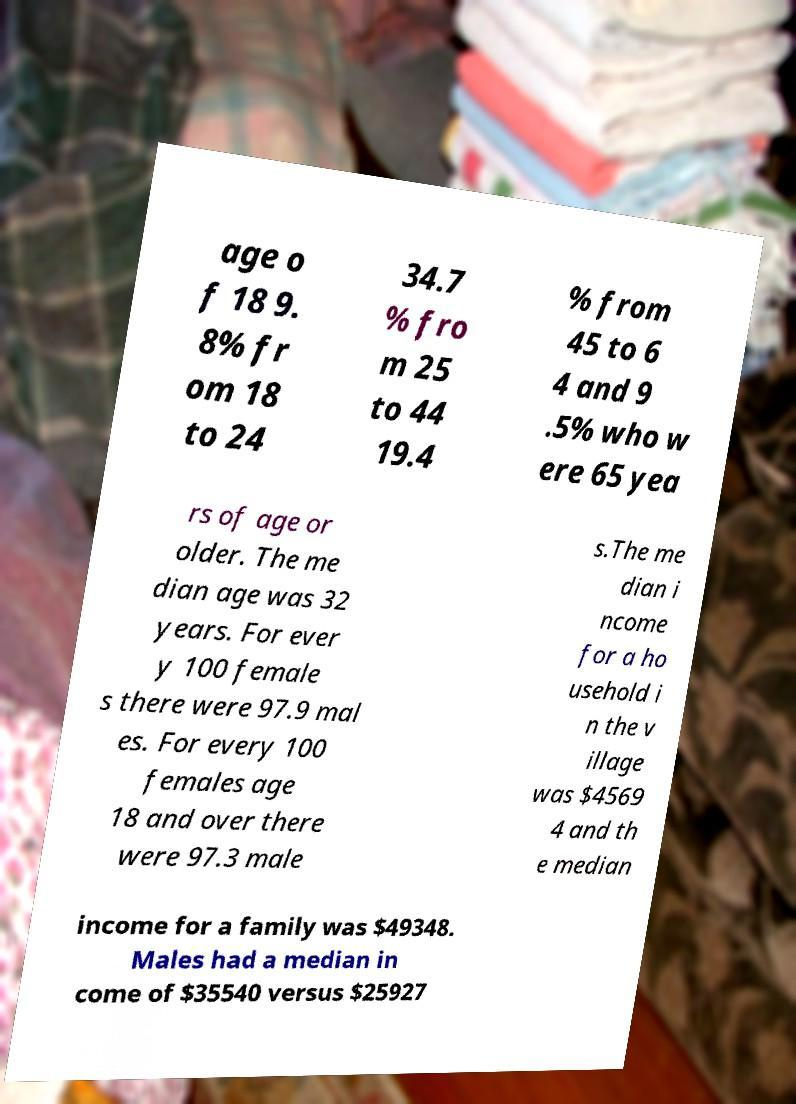Can you accurately transcribe the text from the provided image for me? age o f 18 9. 8% fr om 18 to 24 34.7 % fro m 25 to 44 19.4 % from 45 to 6 4 and 9 .5% who w ere 65 yea rs of age or older. The me dian age was 32 years. For ever y 100 female s there were 97.9 mal es. For every 100 females age 18 and over there were 97.3 male s.The me dian i ncome for a ho usehold i n the v illage was $4569 4 and th e median income for a family was $49348. Males had a median in come of $35540 versus $25927 